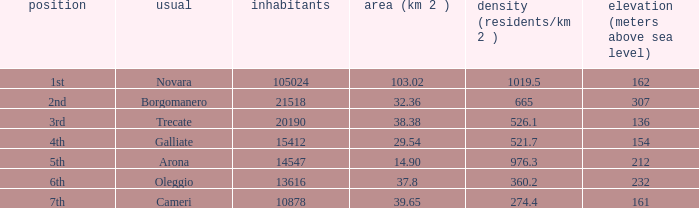02? Novara. 